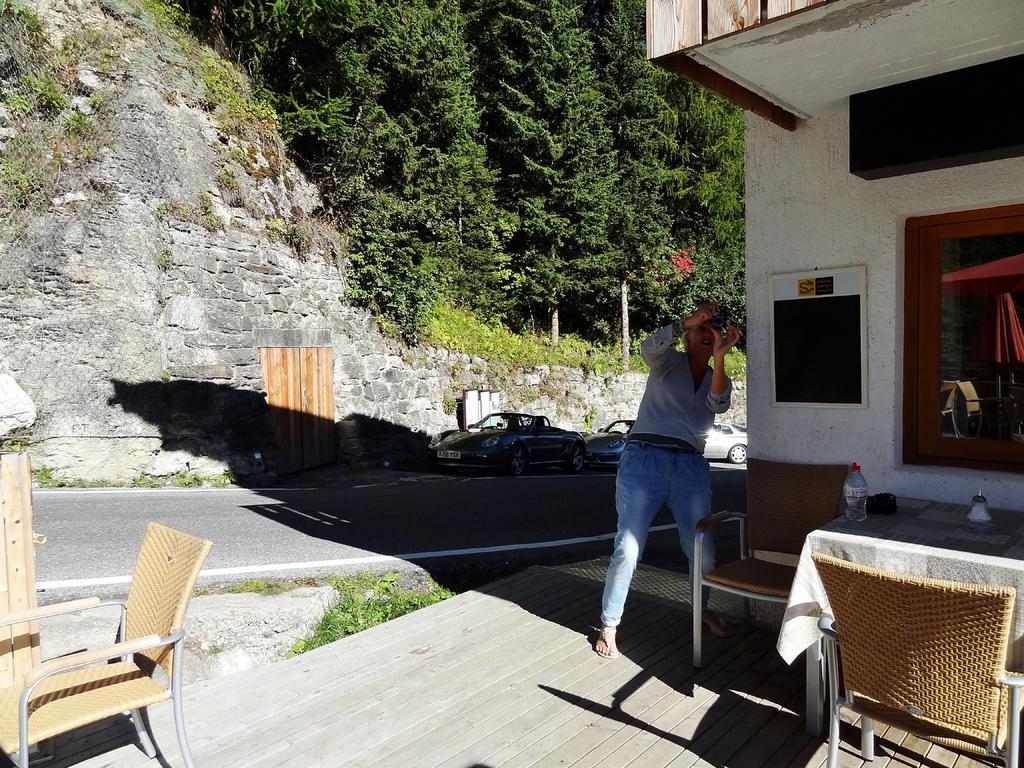Please provide a concise description of this image. In this picture we can see a bottle on the table, and a man is taking a picture with camera and also we can see a building couple of cars and couple of trees. 